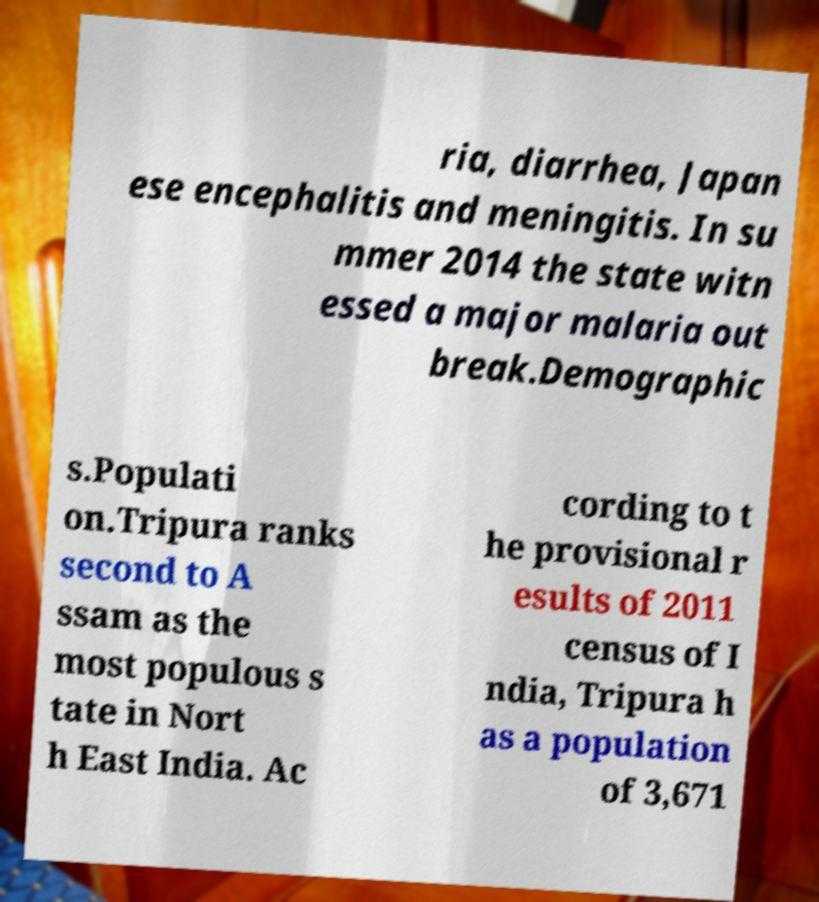There's text embedded in this image that I need extracted. Can you transcribe it verbatim? ria, diarrhea, Japan ese encephalitis and meningitis. In su mmer 2014 the state witn essed a major malaria out break.Demographic s.Populati on.Tripura ranks second to A ssam as the most populous s tate in Nort h East India. Ac cording to t he provisional r esults of 2011 census of I ndia, Tripura h as a population of 3,671 